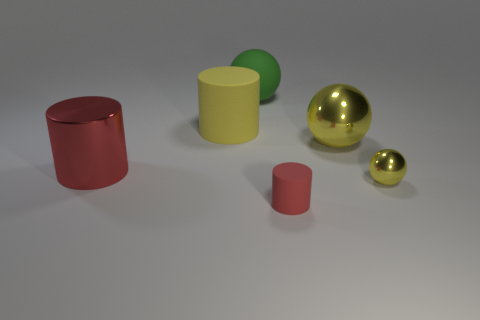There is a big thing that is the same color as the small rubber thing; what is its shape?
Offer a very short reply. Cylinder. The small rubber thing is what color?
Your answer should be compact. Red. There is a red object that is behind the red rubber cylinder; what is its size?
Ensure brevity in your answer.  Large. How many spheres have the same color as the shiny cylinder?
Your response must be concise. 0. Are there any red rubber things left of the shiny object on the left side of the large yellow cylinder?
Keep it short and to the point. No. Does the matte cylinder that is in front of the tiny yellow ball have the same color as the cylinder to the left of the yellow matte object?
Keep it short and to the point. Yes. There is a rubber ball that is the same size as the red shiny cylinder; what color is it?
Keep it short and to the point. Green. Are there an equal number of tiny red things that are to the left of the large yellow metal object and matte objects that are on the left side of the green ball?
Offer a very short reply. Yes. What material is the large yellow thing that is on the right side of the rubber cylinder that is in front of the big yellow cylinder made of?
Offer a very short reply. Metal. What number of objects are big green spheres or yellow metal things?
Keep it short and to the point. 3. 